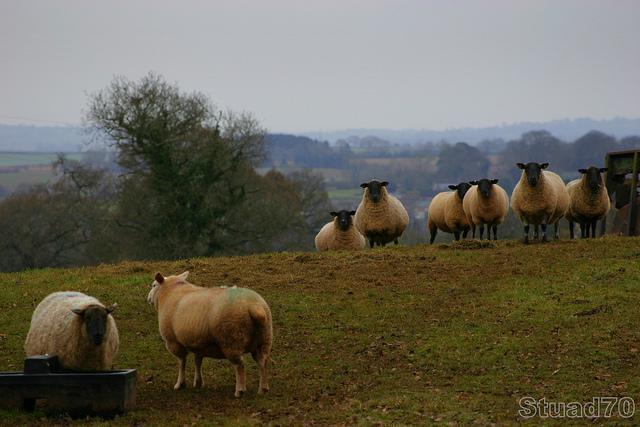How many sheep are there?
Give a very brief answer. 8. How many sheep are looking towards the camera?
Give a very brief answer. 7. 